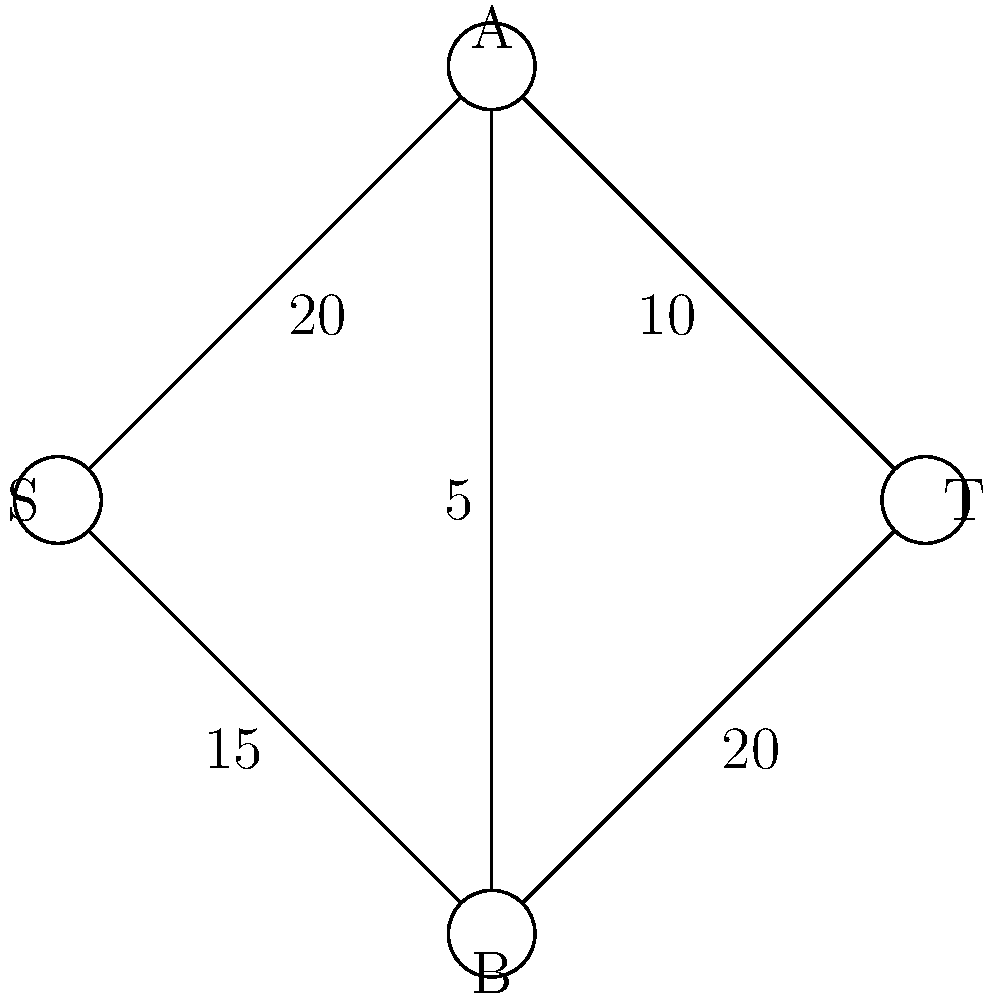In a climate finance network, nodes represent different sectors (S: source, T: sink, A: renewable energy, B: energy efficiency). Edges represent fund allocation capacities (in million euros). What is the maximum flow from S to T, and how should funds be allocated to maximize climate mitigation efforts? To solve this maximum flow problem, we'll use the Ford-Fulkerson algorithm:

1. Initialize flow to 0 for all edges.

2. Find an augmenting path from S to T:
   Path 1: S → A → T (min capacity: 10)
   Update flow: S → A: 10, A → T: 10
   Residual capacities: S → A: 10, A → T: 0

3. Find another augmenting path:
   Path 2: S → B → T (min capacity: 15)
   Update flow: S → B: 15, B → T: 15
   Residual capacities: S → B: 0, B → T: 5

4. Find another augmenting path:
   Path 3: S → A → B → T (min capacity: 5)
   Update flow: S → A: 15, A → B: 5, B → T: 20
   Residual capacities: S → A: 5, A → B: 0, B → T: 0

5. No more augmenting paths exist, so the algorithm terminates.

The maximum flow is the sum of all flows out of S: 15 + 15 = 30 million euros.

Fund allocation:
- 15 million euros to renewable energy sector (A)
- 15 million euros to energy efficiency sector (B)
- 5 million euros transferred from renewable energy to energy efficiency

This allocation maximizes the total climate mitigation effort while respecting the capacity constraints of each sector and the transfer limitations between sectors.
Answer: Maximum flow: 30 million euros. Allocation: 15 to renewable energy, 15 to energy efficiency, with 5 transferred between sectors. 